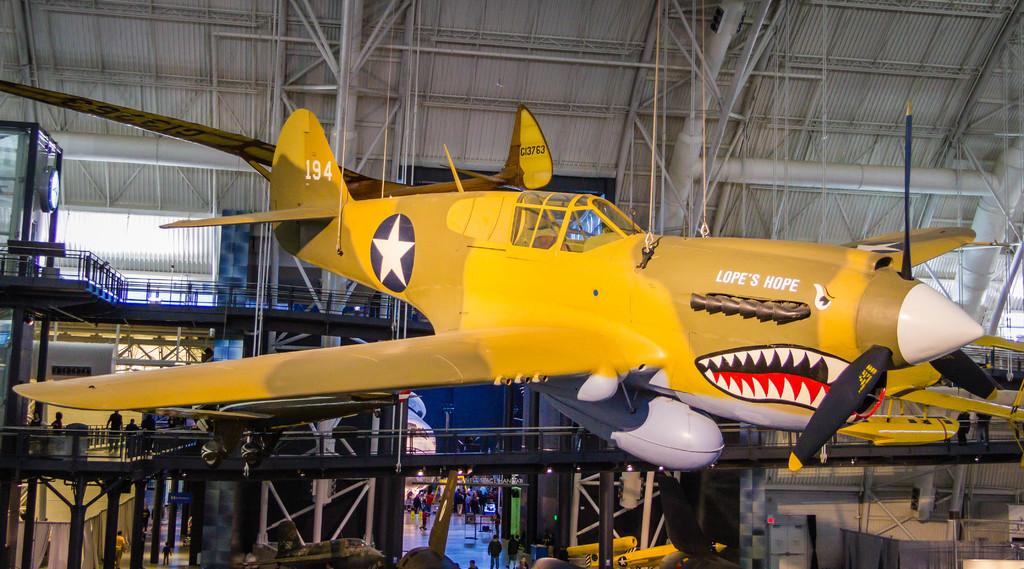How is the plane positioned in the image? The plane is hanging in the air with ropes in the image. Can you describe the people visible in the image? There are people visible in the image, but their specific actions or positions are not mentioned in the facts. What type of structure can be seen in the image? There is a bridge in the image. What architectural elements support the bridge? Pillars are present in the image to support the bridge. From where was the image taken? The image was taken from a rooftop. What type of stream can be seen flowing under the bridge in the image? There is no stream visible in the image; only a bridge and pillars are mentioned. How many crows are perched on the plane in the image? There are no crows present in the image. 